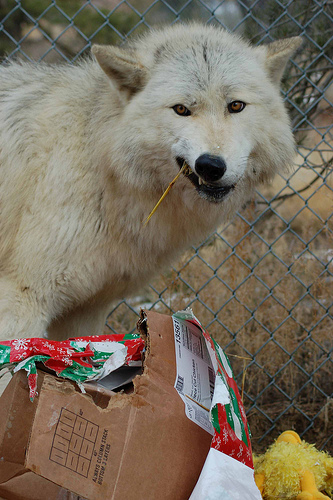<image>
Can you confirm if the box is in front of the wolf? Yes. The box is positioned in front of the wolf, appearing closer to the camera viewpoint. 